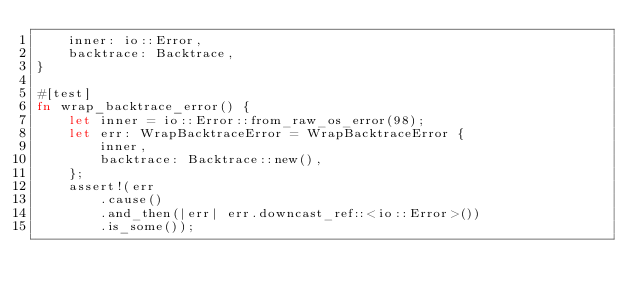<code> <loc_0><loc_0><loc_500><loc_500><_Rust_>    inner: io::Error,
    backtrace: Backtrace,
}

#[test]
fn wrap_backtrace_error() {
    let inner = io::Error::from_raw_os_error(98);
    let err: WrapBacktraceError = WrapBacktraceError {
        inner,
        backtrace: Backtrace::new(),
    };
    assert!(err
        .cause()
        .and_then(|err| err.downcast_ref::<io::Error>())
        .is_some());</code> 